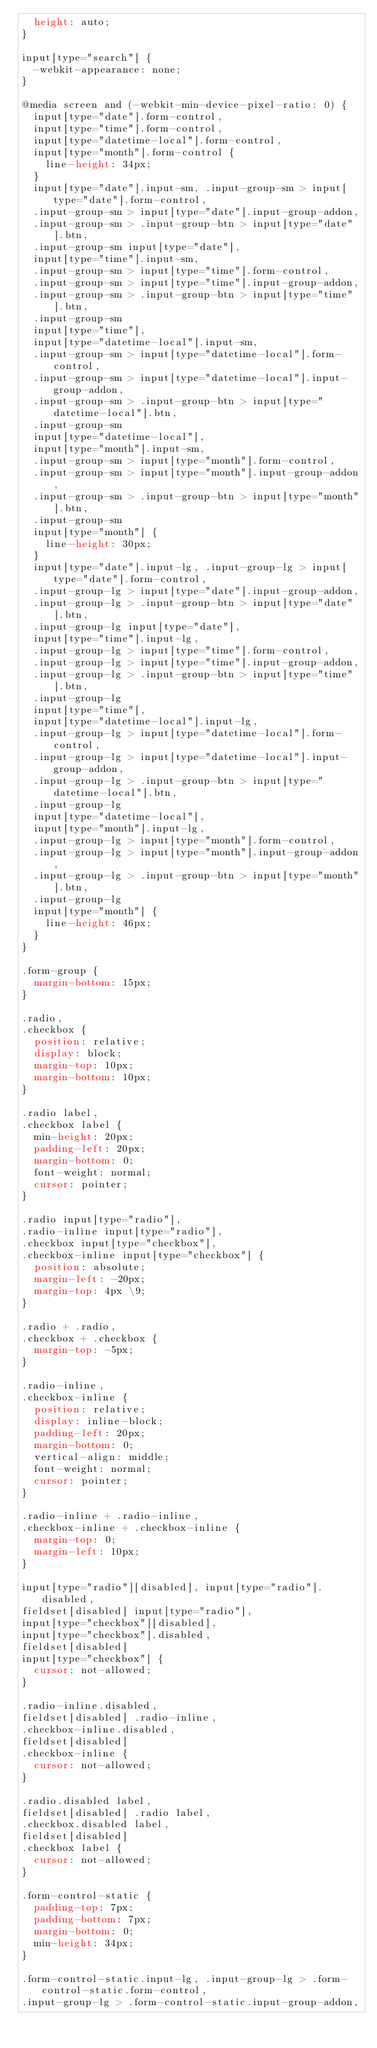Convert code to text. <code><loc_0><loc_0><loc_500><loc_500><_CSS_>  height: auto;
}

input[type="search"] {
  -webkit-appearance: none;
}

@media screen and (-webkit-min-device-pixel-ratio: 0) {
  input[type="date"].form-control,
  input[type="time"].form-control,
  input[type="datetime-local"].form-control,
  input[type="month"].form-control {
    line-height: 34px;
  }
  input[type="date"].input-sm, .input-group-sm > input[type="date"].form-control,
  .input-group-sm > input[type="date"].input-group-addon,
  .input-group-sm > .input-group-btn > input[type="date"].btn,
  .input-group-sm input[type="date"],
  input[type="time"].input-sm,
  .input-group-sm > input[type="time"].form-control,
  .input-group-sm > input[type="time"].input-group-addon,
  .input-group-sm > .input-group-btn > input[type="time"].btn,
  .input-group-sm
  input[type="time"],
  input[type="datetime-local"].input-sm,
  .input-group-sm > input[type="datetime-local"].form-control,
  .input-group-sm > input[type="datetime-local"].input-group-addon,
  .input-group-sm > .input-group-btn > input[type="datetime-local"].btn,
  .input-group-sm
  input[type="datetime-local"],
  input[type="month"].input-sm,
  .input-group-sm > input[type="month"].form-control,
  .input-group-sm > input[type="month"].input-group-addon,
  .input-group-sm > .input-group-btn > input[type="month"].btn,
  .input-group-sm
  input[type="month"] {
    line-height: 30px;
  }
  input[type="date"].input-lg, .input-group-lg > input[type="date"].form-control,
  .input-group-lg > input[type="date"].input-group-addon,
  .input-group-lg > .input-group-btn > input[type="date"].btn,
  .input-group-lg input[type="date"],
  input[type="time"].input-lg,
  .input-group-lg > input[type="time"].form-control,
  .input-group-lg > input[type="time"].input-group-addon,
  .input-group-lg > .input-group-btn > input[type="time"].btn,
  .input-group-lg
  input[type="time"],
  input[type="datetime-local"].input-lg,
  .input-group-lg > input[type="datetime-local"].form-control,
  .input-group-lg > input[type="datetime-local"].input-group-addon,
  .input-group-lg > .input-group-btn > input[type="datetime-local"].btn,
  .input-group-lg
  input[type="datetime-local"],
  input[type="month"].input-lg,
  .input-group-lg > input[type="month"].form-control,
  .input-group-lg > input[type="month"].input-group-addon,
  .input-group-lg > .input-group-btn > input[type="month"].btn,
  .input-group-lg
  input[type="month"] {
    line-height: 46px;
  }
}

.form-group {
  margin-bottom: 15px;
}

.radio,
.checkbox {
  position: relative;
  display: block;
  margin-top: 10px;
  margin-bottom: 10px;
}

.radio label,
.checkbox label {
  min-height: 20px;
  padding-left: 20px;
  margin-bottom: 0;
  font-weight: normal;
  cursor: pointer;
}

.radio input[type="radio"],
.radio-inline input[type="radio"],
.checkbox input[type="checkbox"],
.checkbox-inline input[type="checkbox"] {
  position: absolute;
  margin-left: -20px;
  margin-top: 4px \9;
}

.radio + .radio,
.checkbox + .checkbox {
  margin-top: -5px;
}

.radio-inline,
.checkbox-inline {
  position: relative;
  display: inline-block;
  padding-left: 20px;
  margin-bottom: 0;
  vertical-align: middle;
  font-weight: normal;
  cursor: pointer;
}

.radio-inline + .radio-inline,
.checkbox-inline + .checkbox-inline {
  margin-top: 0;
  margin-left: 10px;
}

input[type="radio"][disabled], input[type="radio"].disabled,
fieldset[disabled] input[type="radio"],
input[type="checkbox"][disabled],
input[type="checkbox"].disabled,
fieldset[disabled]
input[type="checkbox"] {
  cursor: not-allowed;
}

.radio-inline.disabled,
fieldset[disabled] .radio-inline,
.checkbox-inline.disabled,
fieldset[disabled]
.checkbox-inline {
  cursor: not-allowed;
}

.radio.disabled label,
fieldset[disabled] .radio label,
.checkbox.disabled label,
fieldset[disabled]
.checkbox label {
  cursor: not-allowed;
}

.form-control-static {
  padding-top: 7px;
  padding-bottom: 7px;
  margin-bottom: 0;
  min-height: 34px;
}

.form-control-static.input-lg, .input-group-lg > .form-control-static.form-control,
.input-group-lg > .form-control-static.input-group-addon,</code> 